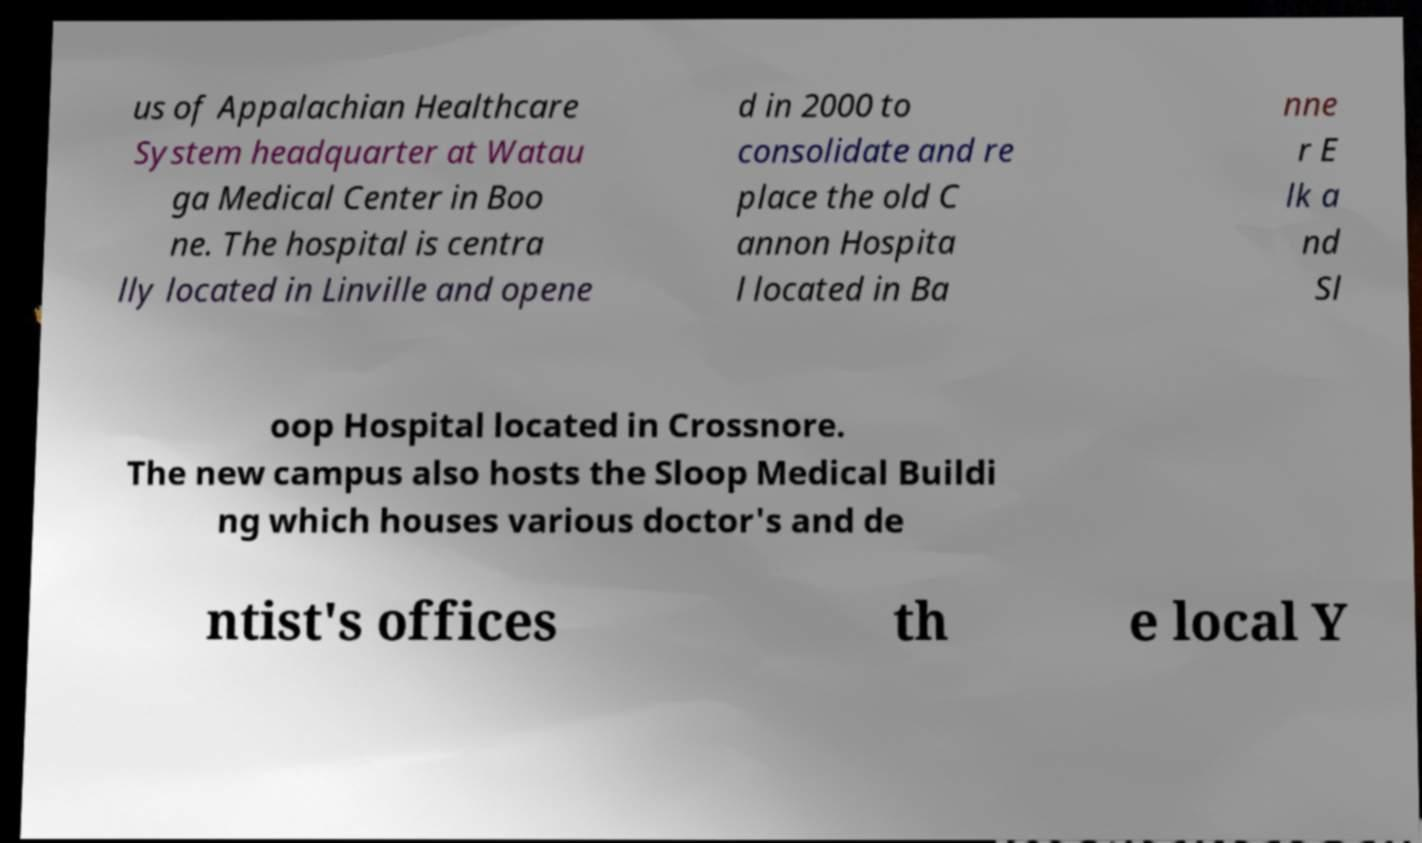Please read and relay the text visible in this image. What does it say? us of Appalachian Healthcare System headquarter at Watau ga Medical Center in Boo ne. The hospital is centra lly located in Linville and opene d in 2000 to consolidate and re place the old C annon Hospita l located in Ba nne r E lk a nd Sl oop Hospital located in Crossnore. The new campus also hosts the Sloop Medical Buildi ng which houses various doctor's and de ntist's offices th e local Y 